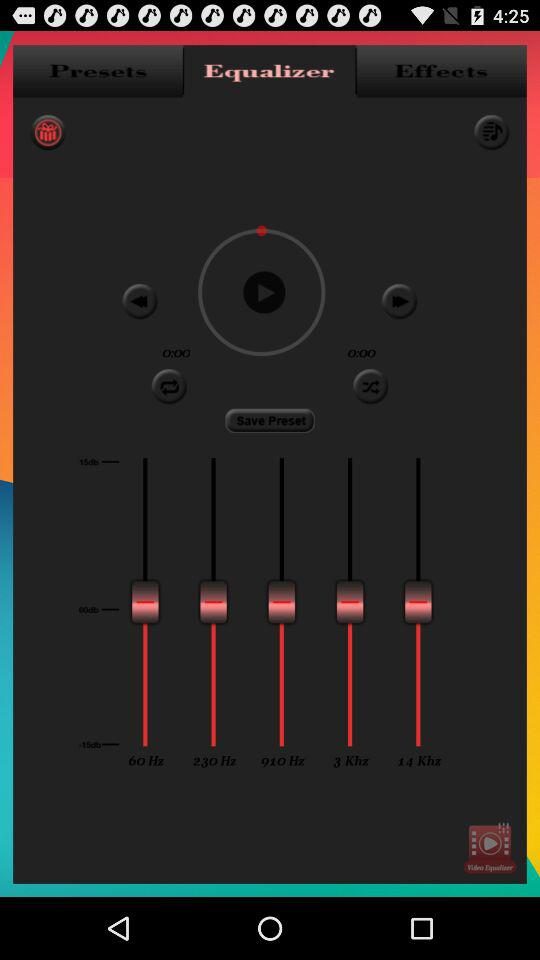What is the time duration?
When the provided information is insufficient, respond with <no answer>. <no answer> 